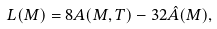Convert formula to latex. <formula><loc_0><loc_0><loc_500><loc_500>L ( M ) = 8 A ( M , T ) - 3 2 \hat { A } ( M ) ,</formula> 